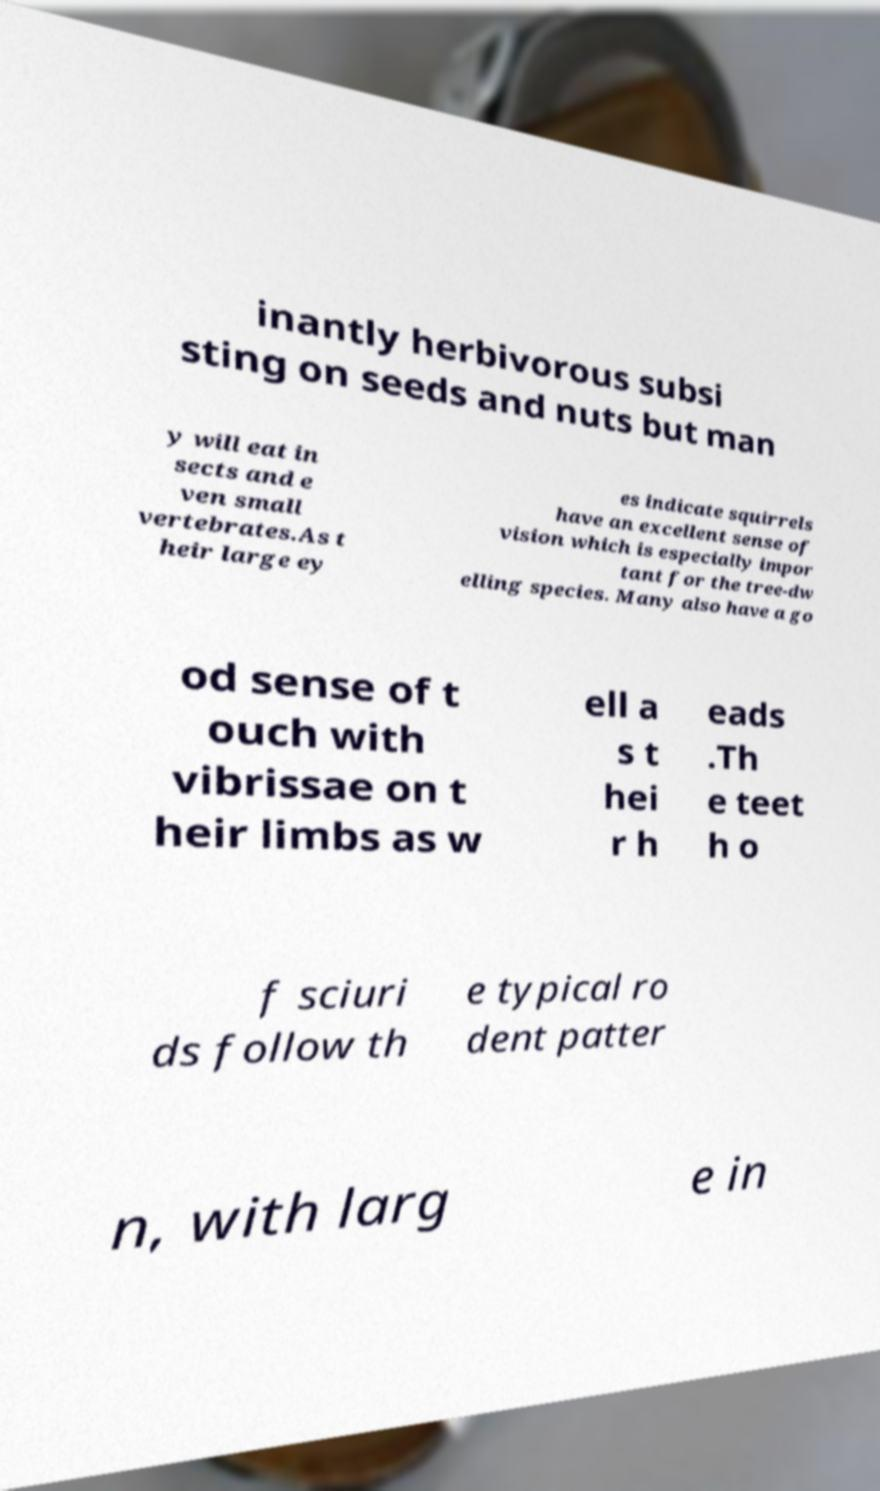Can you accurately transcribe the text from the provided image for me? inantly herbivorous subsi sting on seeds and nuts but man y will eat in sects and e ven small vertebrates.As t heir large ey es indicate squirrels have an excellent sense of vision which is especially impor tant for the tree-dw elling species. Many also have a go od sense of t ouch with vibrissae on t heir limbs as w ell a s t hei r h eads .Th e teet h o f sciuri ds follow th e typical ro dent patter n, with larg e in 